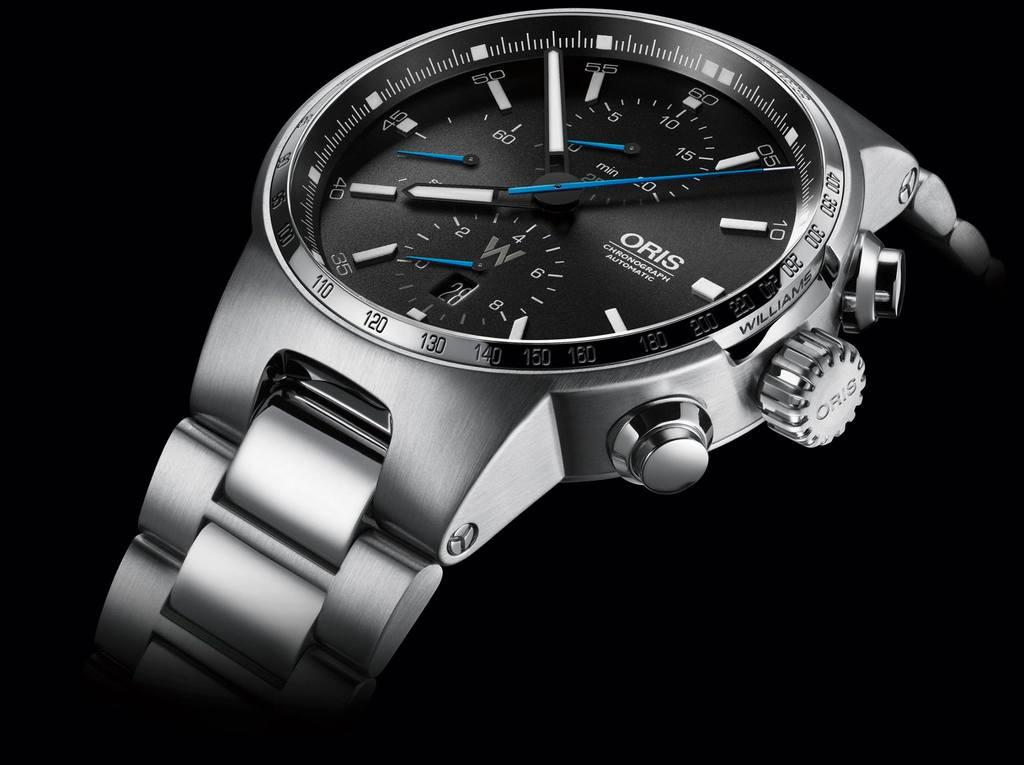<image>
Write a terse but informative summary of the picture. A close up high resolution view of an Oris wristwatch 